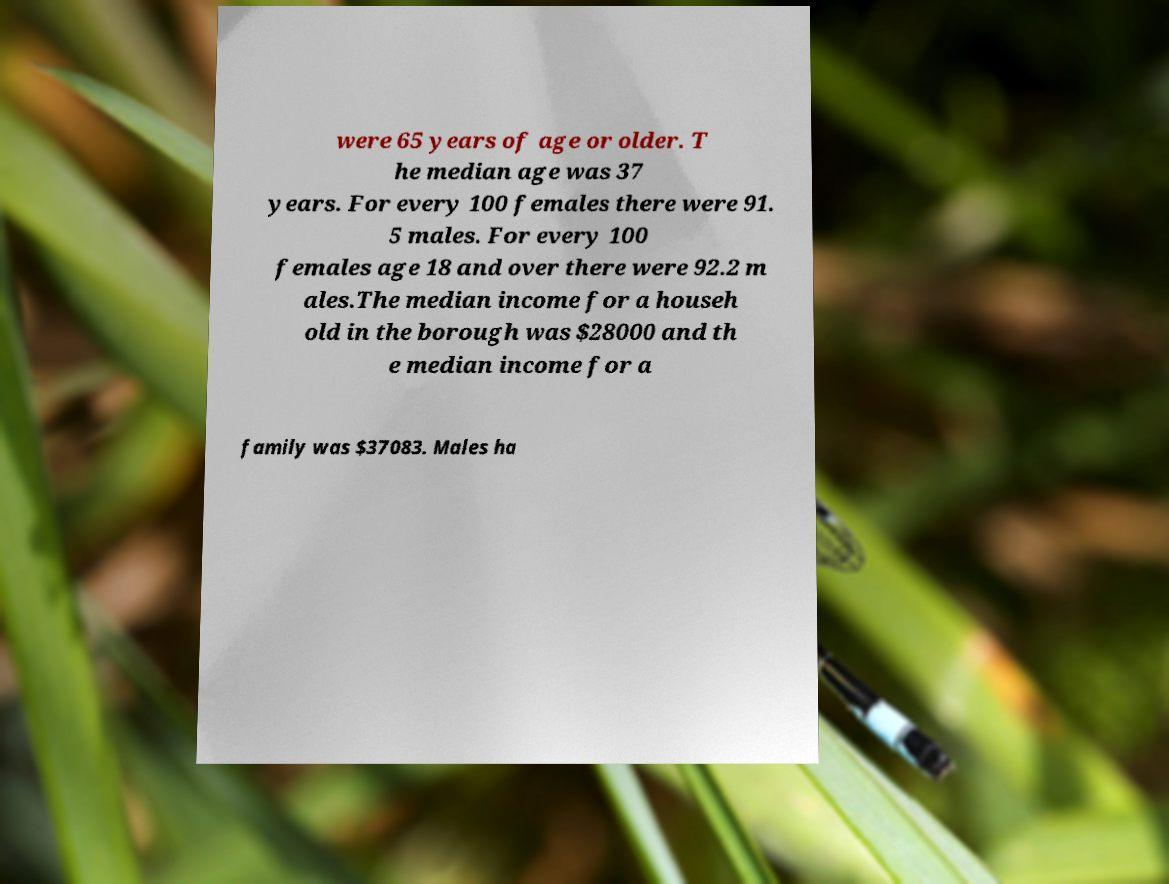There's text embedded in this image that I need extracted. Can you transcribe it verbatim? were 65 years of age or older. T he median age was 37 years. For every 100 females there were 91. 5 males. For every 100 females age 18 and over there were 92.2 m ales.The median income for a househ old in the borough was $28000 and th e median income for a family was $37083. Males ha 